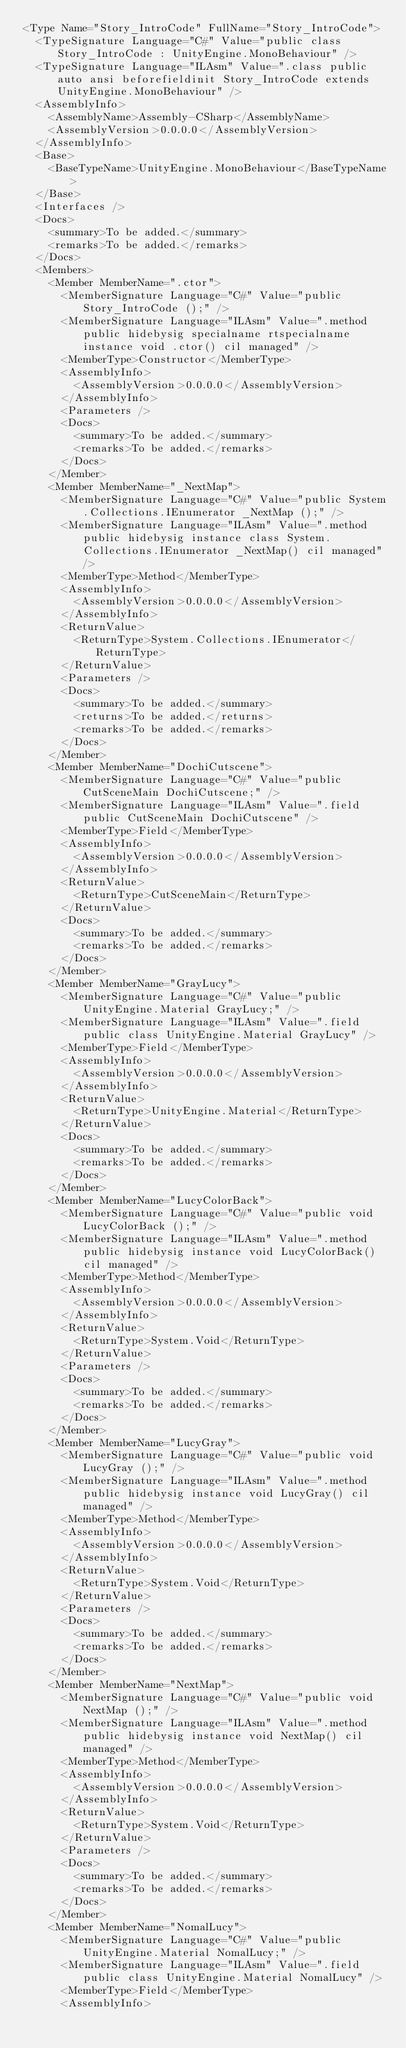<code> <loc_0><loc_0><loc_500><loc_500><_XML_><Type Name="Story_IntroCode" FullName="Story_IntroCode">
  <TypeSignature Language="C#" Value="public class Story_IntroCode : UnityEngine.MonoBehaviour" />
  <TypeSignature Language="ILAsm" Value=".class public auto ansi beforefieldinit Story_IntroCode extends UnityEngine.MonoBehaviour" />
  <AssemblyInfo>
    <AssemblyName>Assembly-CSharp</AssemblyName>
    <AssemblyVersion>0.0.0.0</AssemblyVersion>
  </AssemblyInfo>
  <Base>
    <BaseTypeName>UnityEngine.MonoBehaviour</BaseTypeName>
  </Base>
  <Interfaces />
  <Docs>
    <summary>To be added.</summary>
    <remarks>To be added.</remarks>
  </Docs>
  <Members>
    <Member MemberName=".ctor">
      <MemberSignature Language="C#" Value="public Story_IntroCode ();" />
      <MemberSignature Language="ILAsm" Value=".method public hidebysig specialname rtspecialname instance void .ctor() cil managed" />
      <MemberType>Constructor</MemberType>
      <AssemblyInfo>
        <AssemblyVersion>0.0.0.0</AssemblyVersion>
      </AssemblyInfo>
      <Parameters />
      <Docs>
        <summary>To be added.</summary>
        <remarks>To be added.</remarks>
      </Docs>
    </Member>
    <Member MemberName="_NextMap">
      <MemberSignature Language="C#" Value="public System.Collections.IEnumerator _NextMap ();" />
      <MemberSignature Language="ILAsm" Value=".method public hidebysig instance class System.Collections.IEnumerator _NextMap() cil managed" />
      <MemberType>Method</MemberType>
      <AssemblyInfo>
        <AssemblyVersion>0.0.0.0</AssemblyVersion>
      </AssemblyInfo>
      <ReturnValue>
        <ReturnType>System.Collections.IEnumerator</ReturnType>
      </ReturnValue>
      <Parameters />
      <Docs>
        <summary>To be added.</summary>
        <returns>To be added.</returns>
        <remarks>To be added.</remarks>
      </Docs>
    </Member>
    <Member MemberName="DochiCutscene">
      <MemberSignature Language="C#" Value="public CutSceneMain DochiCutscene;" />
      <MemberSignature Language="ILAsm" Value=".field public CutSceneMain DochiCutscene" />
      <MemberType>Field</MemberType>
      <AssemblyInfo>
        <AssemblyVersion>0.0.0.0</AssemblyVersion>
      </AssemblyInfo>
      <ReturnValue>
        <ReturnType>CutSceneMain</ReturnType>
      </ReturnValue>
      <Docs>
        <summary>To be added.</summary>
        <remarks>To be added.</remarks>
      </Docs>
    </Member>
    <Member MemberName="GrayLucy">
      <MemberSignature Language="C#" Value="public UnityEngine.Material GrayLucy;" />
      <MemberSignature Language="ILAsm" Value=".field public class UnityEngine.Material GrayLucy" />
      <MemberType>Field</MemberType>
      <AssemblyInfo>
        <AssemblyVersion>0.0.0.0</AssemblyVersion>
      </AssemblyInfo>
      <ReturnValue>
        <ReturnType>UnityEngine.Material</ReturnType>
      </ReturnValue>
      <Docs>
        <summary>To be added.</summary>
        <remarks>To be added.</remarks>
      </Docs>
    </Member>
    <Member MemberName="LucyColorBack">
      <MemberSignature Language="C#" Value="public void LucyColorBack ();" />
      <MemberSignature Language="ILAsm" Value=".method public hidebysig instance void LucyColorBack() cil managed" />
      <MemberType>Method</MemberType>
      <AssemblyInfo>
        <AssemblyVersion>0.0.0.0</AssemblyVersion>
      </AssemblyInfo>
      <ReturnValue>
        <ReturnType>System.Void</ReturnType>
      </ReturnValue>
      <Parameters />
      <Docs>
        <summary>To be added.</summary>
        <remarks>To be added.</remarks>
      </Docs>
    </Member>
    <Member MemberName="LucyGray">
      <MemberSignature Language="C#" Value="public void LucyGray ();" />
      <MemberSignature Language="ILAsm" Value=".method public hidebysig instance void LucyGray() cil managed" />
      <MemberType>Method</MemberType>
      <AssemblyInfo>
        <AssemblyVersion>0.0.0.0</AssemblyVersion>
      </AssemblyInfo>
      <ReturnValue>
        <ReturnType>System.Void</ReturnType>
      </ReturnValue>
      <Parameters />
      <Docs>
        <summary>To be added.</summary>
        <remarks>To be added.</remarks>
      </Docs>
    </Member>
    <Member MemberName="NextMap">
      <MemberSignature Language="C#" Value="public void NextMap ();" />
      <MemberSignature Language="ILAsm" Value=".method public hidebysig instance void NextMap() cil managed" />
      <MemberType>Method</MemberType>
      <AssemblyInfo>
        <AssemblyVersion>0.0.0.0</AssemblyVersion>
      </AssemblyInfo>
      <ReturnValue>
        <ReturnType>System.Void</ReturnType>
      </ReturnValue>
      <Parameters />
      <Docs>
        <summary>To be added.</summary>
        <remarks>To be added.</remarks>
      </Docs>
    </Member>
    <Member MemberName="NomalLucy">
      <MemberSignature Language="C#" Value="public UnityEngine.Material NomalLucy;" />
      <MemberSignature Language="ILAsm" Value=".field public class UnityEngine.Material NomalLucy" />
      <MemberType>Field</MemberType>
      <AssemblyInfo></code> 